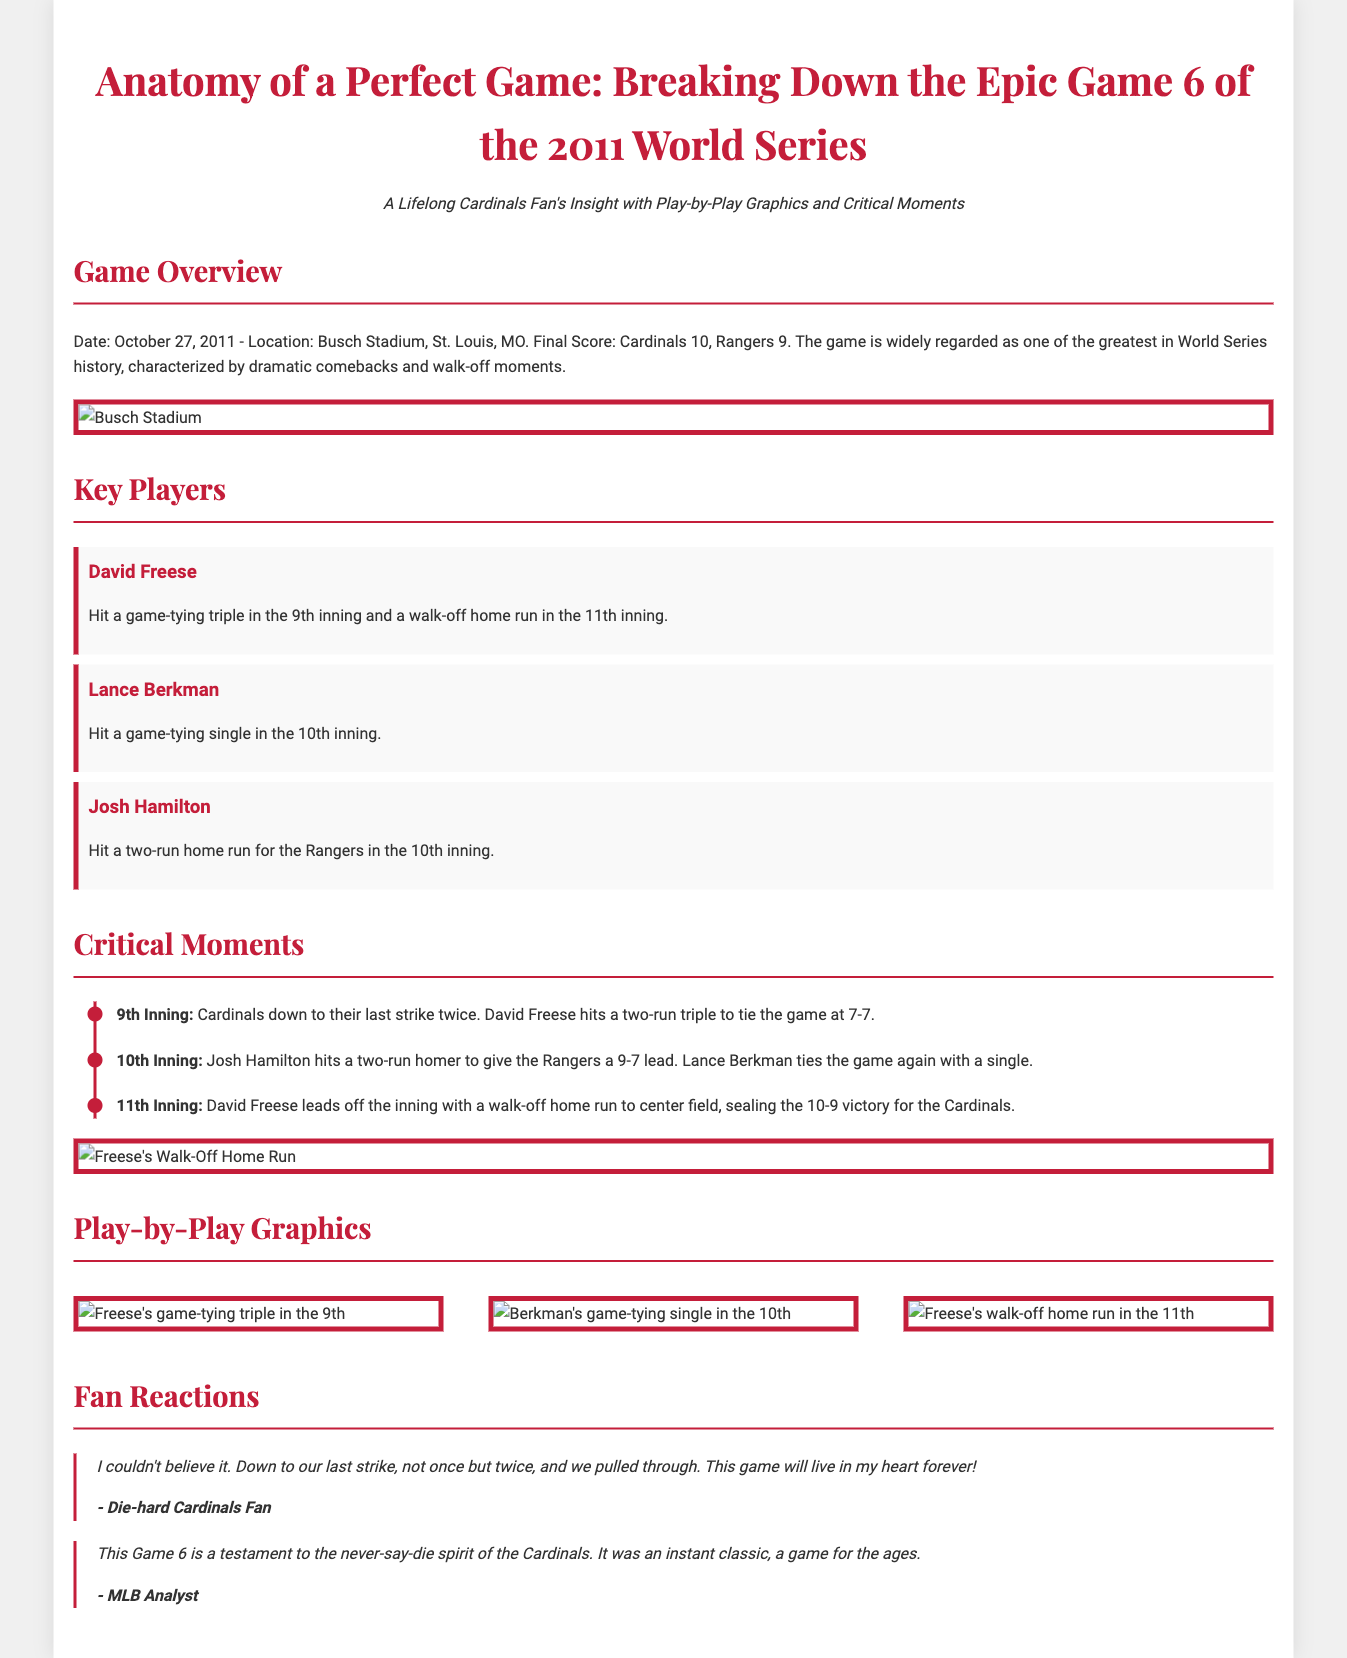What is the final score of Game 6? The final score of the game, as stated in the overview, was Cardinals 10, Rangers 9.
Answer: Cardinals 10, Rangers 9 Who hit a game-tying triple in the 9th inning? The document specifies that David Freese hit a game-tying triple in the 9th inning.
Answer: David Freese What significant event occurred in the 11th inning? The infographic mentions that David Freese hit a walk-off home run in the 11th inning, sealing the victory.
Answer: Walk-off home run How many runs did the Rangers lead by in the 10th inning? The timeline states that the Rangers had a 9-7 lead in the 10th inning after Josh Hamilton's homer.
Answer: 9-7 What is the date of Game 6? The game took place on October 27, 2011, as indicated in the game overview.
Answer: October 27, 2011 Which two players are mentioned for hitting significant runs? The document lists David Freese and Lance Berkman for their key hits during critical points in the game.
Answer: David Freese, Lance Berkman What type of content is primarily featured in the infographic? The infographic is made up of a combination of explanatory text, player highlights, and play-by-play graphics covering Game 6.
Answer: Explanatory text and graphics What unique design element is present in the document? The infographic uses a timeline format to narrate the critical moments, making it visually engaging and informative.
Answer: Timeline format 